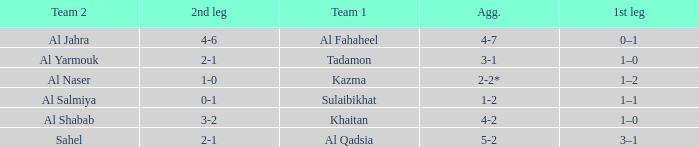What is the 1st leg of the Al Fahaheel Team 1? 0–1. 